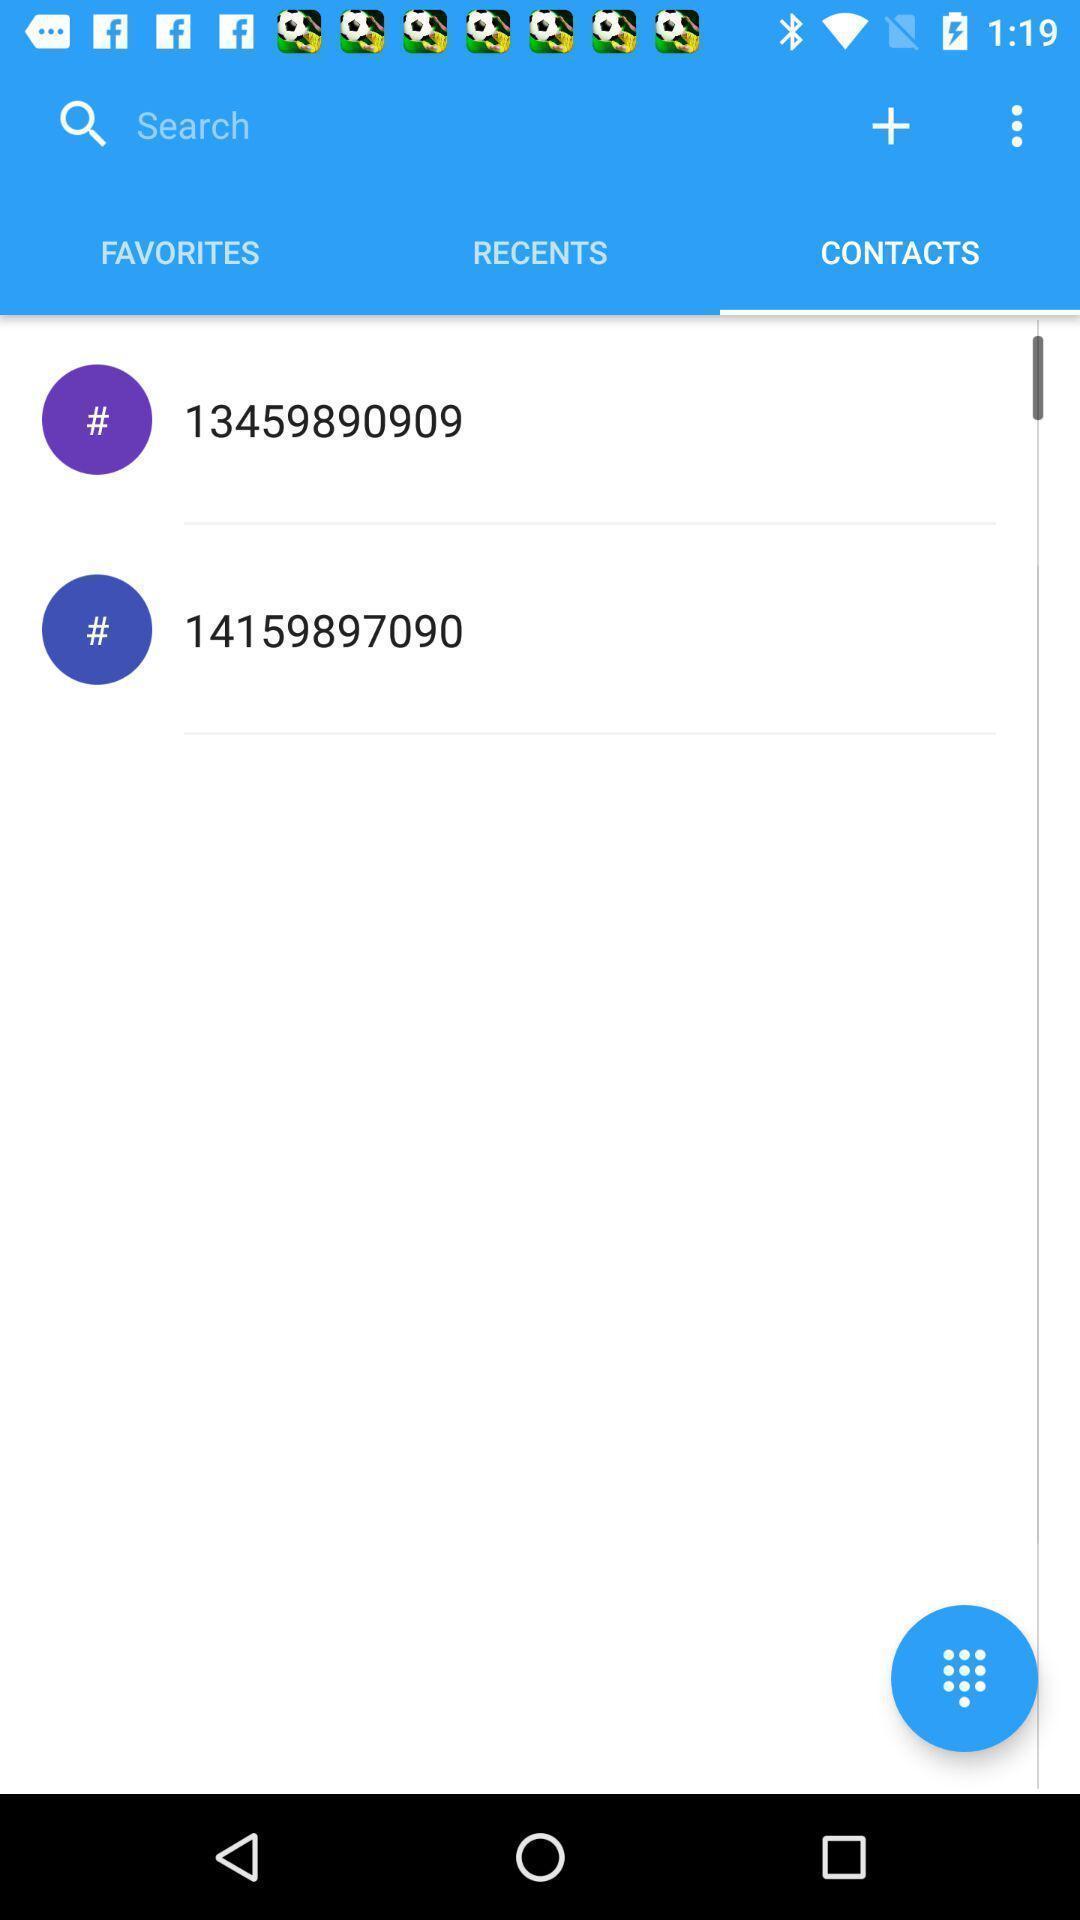Summarize the main components in this picture. Screen displaying contacts information and a keypad icon. 